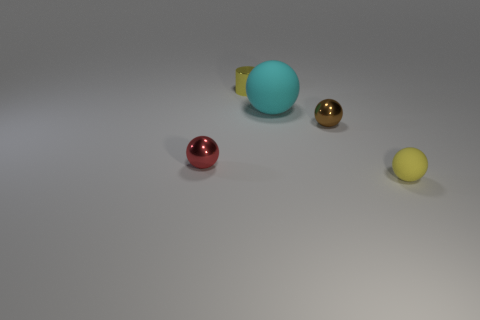Are there any other things that have the same size as the cyan rubber thing?
Your answer should be compact. No. There is a shiny thing that is to the left of the large cyan ball and in front of the big matte object; what size is it?
Make the answer very short. Small. The yellow matte object is what shape?
Make the answer very short. Sphere. How many other small things have the same shape as the tiny brown thing?
Provide a short and direct response. 2. Are there fewer brown things left of the large sphere than yellow metallic objects in front of the tiny yellow shiny cylinder?
Provide a succinct answer. No. What number of tiny red metallic objects are in front of the object that is in front of the red ball?
Provide a short and direct response. 0. Is there a tiny yellow matte ball?
Your answer should be very brief. Yes. Is there a large thing made of the same material as the small yellow ball?
Provide a short and direct response. Yes. Are there more rubber objects in front of the small red metallic ball than large rubber spheres in front of the large ball?
Provide a succinct answer. Yes. Do the red ball and the cyan object have the same size?
Keep it short and to the point. No. 